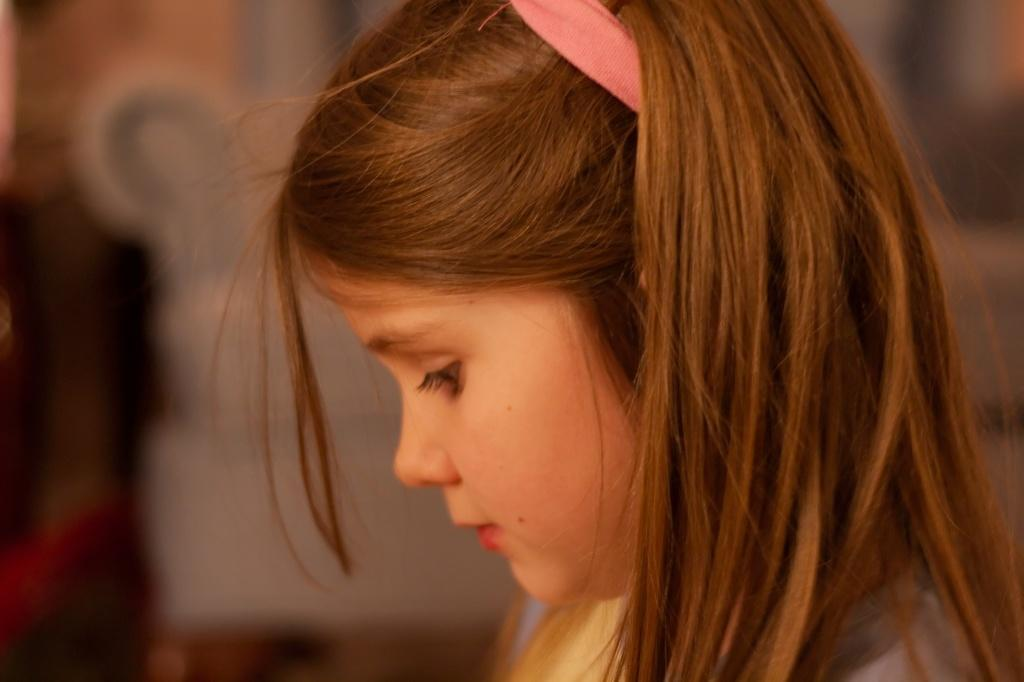Who is the main subject in the image? There is a woman in the image. In which direction is the woman facing? The woman is facing towards the left side. What is the woman doing in the image? The woman is looking downwards. Can you describe the background of the image? The background of the image is blurred. What type of soup is the woman holding in the image? There is no soup present in the image; the woman is not holding anything. 